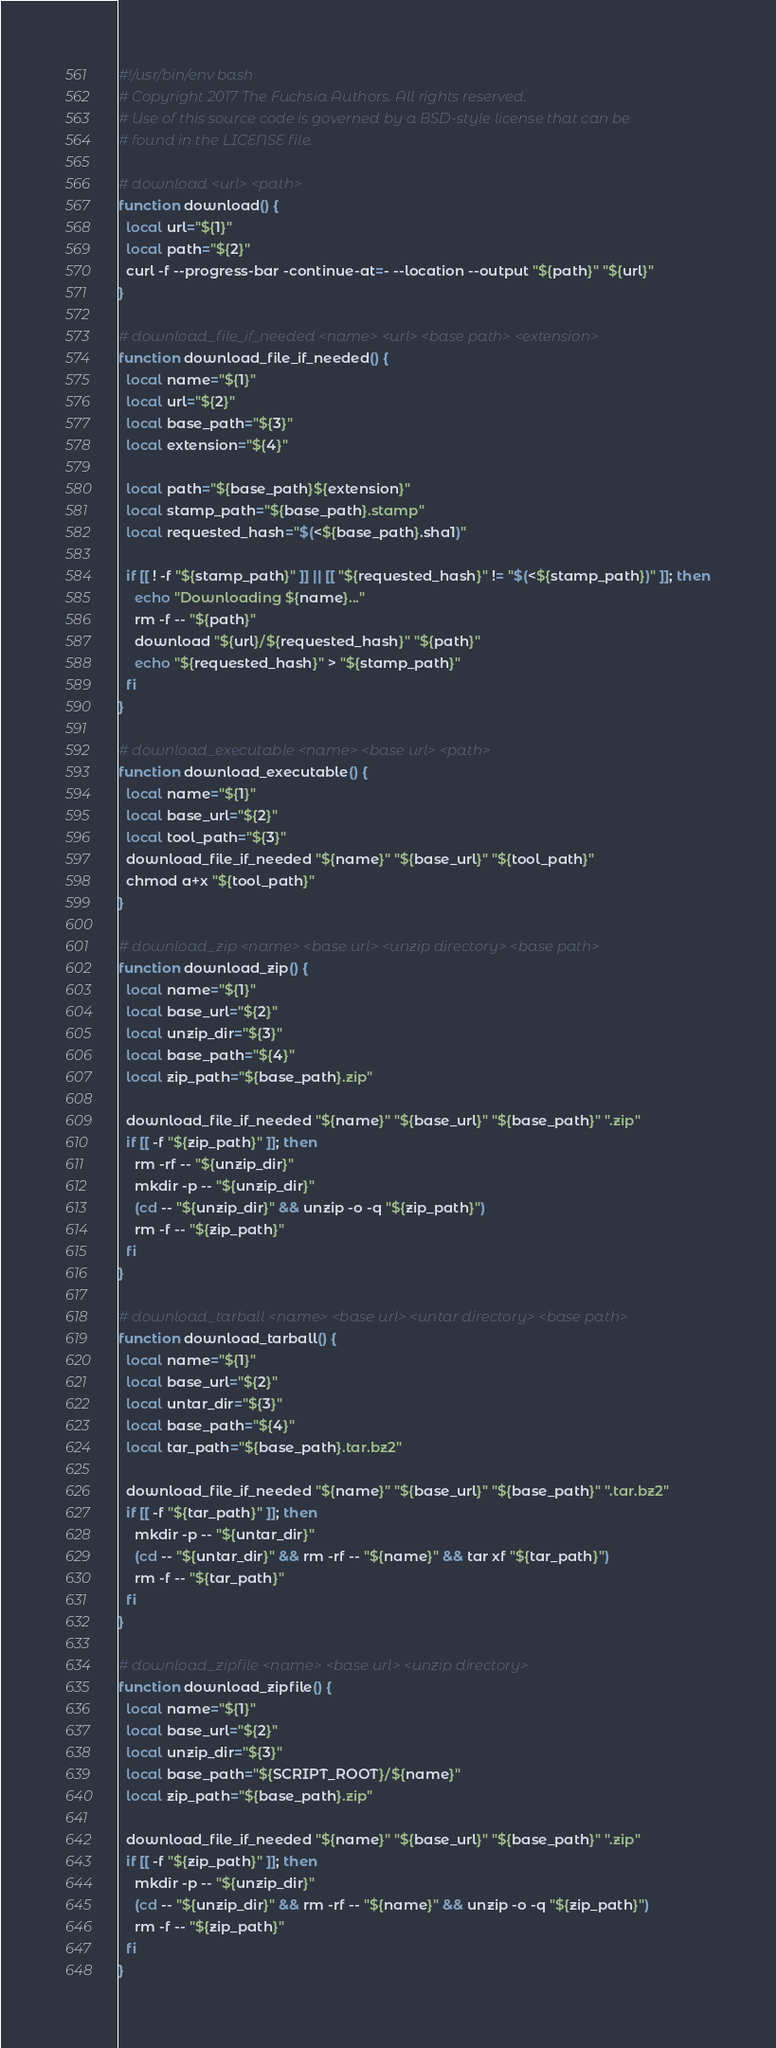<code> <loc_0><loc_0><loc_500><loc_500><_Bash_>#!/usr/bin/env bash
# Copyright 2017 The Fuchsia Authors. All rights reserved.
# Use of this source code is governed by a BSD-style license that can be
# found in the LICENSE file.

# download <url> <path>
function download() {
  local url="${1}"
  local path="${2}"
  curl -f --progress-bar -continue-at=- --location --output "${path}" "${url}"
}

# download_file_if_needed <name> <url> <base path> <extension>
function download_file_if_needed() {
  local name="${1}"
  local url="${2}"
  local base_path="${3}"
  local extension="${4}"

  local path="${base_path}${extension}"
  local stamp_path="${base_path}.stamp"
  local requested_hash="$(<${base_path}.sha1)"

  if [[ ! -f "${stamp_path}" ]] || [[ "${requested_hash}" != "$(<${stamp_path})" ]]; then
    echo "Downloading ${name}..."
    rm -f -- "${path}"
    download "${url}/${requested_hash}" "${path}"
    echo "${requested_hash}" > "${stamp_path}"
  fi
}

# download_executable <name> <base url> <path>
function download_executable() {
  local name="${1}"
  local base_url="${2}"
  local tool_path="${3}"
  download_file_if_needed "${name}" "${base_url}" "${tool_path}"
  chmod a+x "${tool_path}"
}

# download_zip <name> <base url> <unzip directory> <base path>
function download_zip() {
  local name="${1}"
  local base_url="${2}"
  local unzip_dir="${3}"
  local base_path="${4}"
  local zip_path="${base_path}.zip"

  download_file_if_needed "${name}" "${base_url}" "${base_path}" ".zip"
  if [[ -f "${zip_path}" ]]; then
    rm -rf -- "${unzip_dir}"
    mkdir -p -- "${unzip_dir}"
    (cd -- "${unzip_dir}" && unzip -o -q "${zip_path}")
    rm -f -- "${zip_path}"
  fi
}

# download_tarball <name> <base url> <untar directory> <base path>
function download_tarball() {
  local name="${1}"
  local base_url="${2}"
  local untar_dir="${3}"
  local base_path="${4}"
  local tar_path="${base_path}.tar.bz2"

  download_file_if_needed "${name}" "${base_url}" "${base_path}" ".tar.bz2"
  if [[ -f "${tar_path}" ]]; then
    mkdir -p -- "${untar_dir}"
    (cd -- "${untar_dir}" && rm -rf -- "${name}" && tar xf "${tar_path}")
    rm -f -- "${tar_path}"
  fi
}

# download_zipfile <name> <base url> <unzip directory>
function download_zipfile() {
  local name="${1}"
  local base_url="${2}"
  local unzip_dir="${3}"
  local base_path="${SCRIPT_ROOT}/${name}"
  local zip_path="${base_path}.zip"

  download_file_if_needed "${name}" "${base_url}" "${base_path}" ".zip"
  if [[ -f "${zip_path}" ]]; then
    mkdir -p -- "${unzip_dir}"
    (cd -- "${unzip_dir}" && rm -rf -- "${name}" && unzip -o -q "${zip_path}")
    rm -f -- "${zip_path}"
  fi
}
</code> 